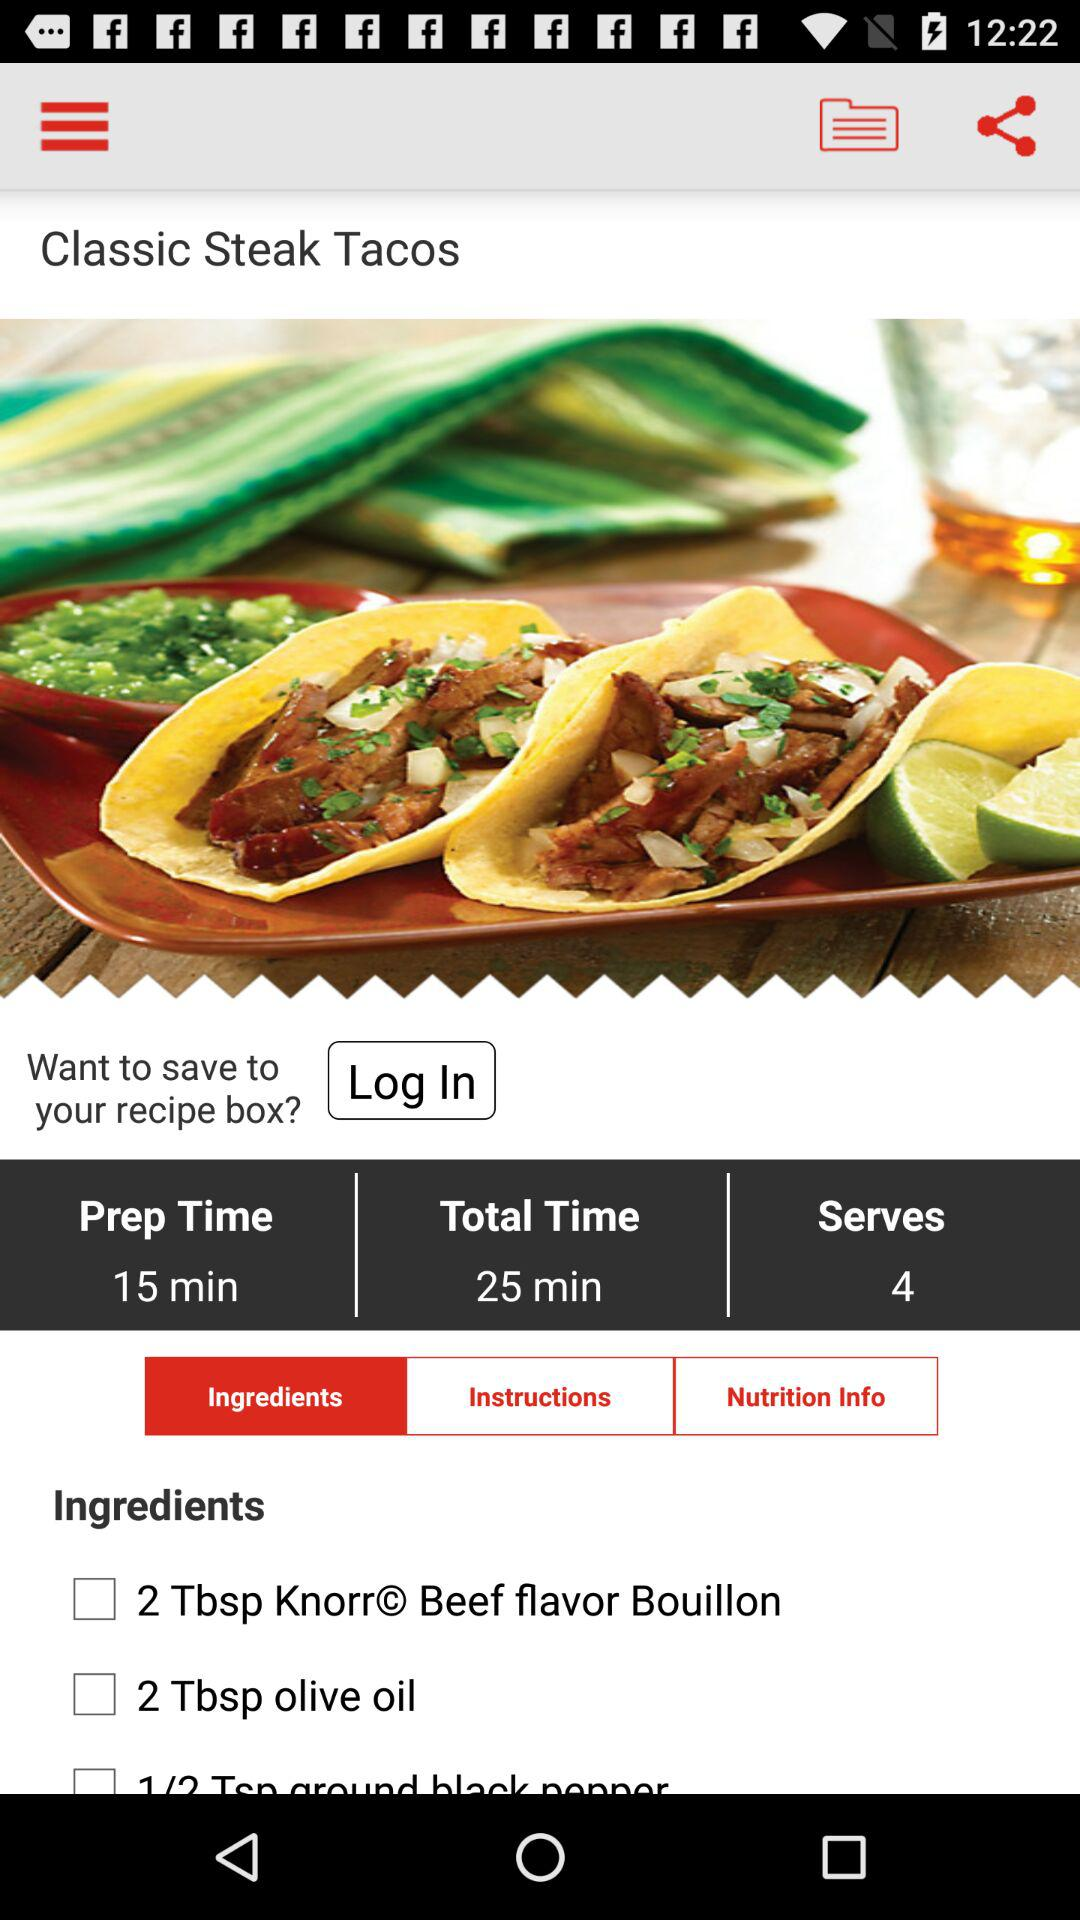What is the name of the dish? The name of the dish is "Classic Steak Tacos". 